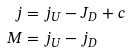<formula> <loc_0><loc_0><loc_500><loc_500>j & = j _ { U } - J _ { D } + c \\ M & = j _ { U } - j _ { D }</formula> 